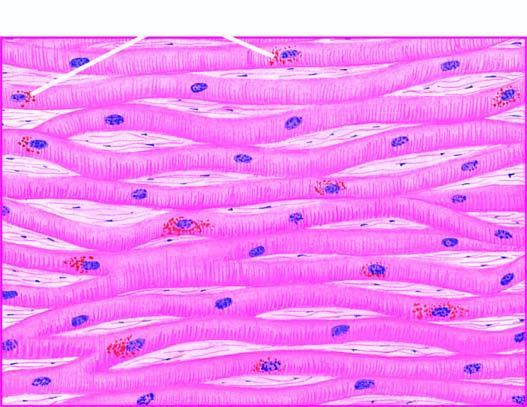re the lipofuscin pigment granules seen in the cytoplasm of the myocardial fibres, especially around the nuclei?
Answer the question using a single word or phrase. Yes 